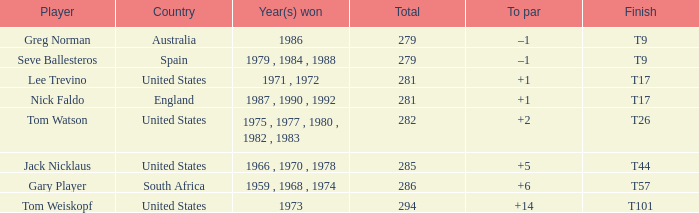From australia, who is the player in question? Greg Norman. 